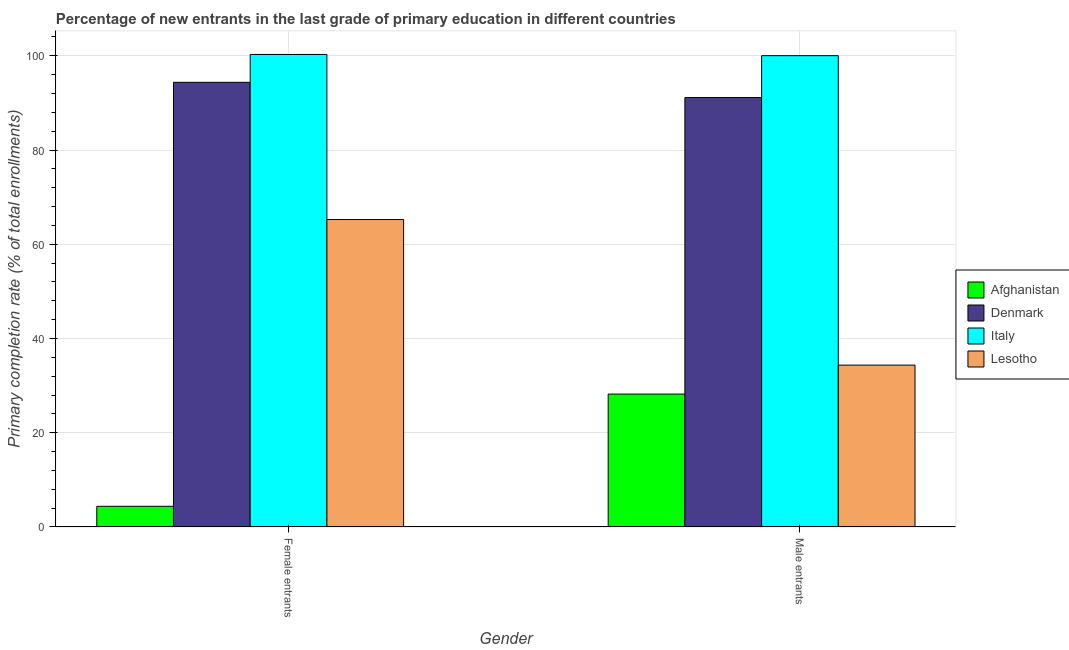How many different coloured bars are there?
Provide a short and direct response. 4. Are the number of bars per tick equal to the number of legend labels?
Provide a succinct answer. Yes. How many bars are there on the 2nd tick from the right?
Offer a very short reply. 4. What is the label of the 1st group of bars from the left?
Make the answer very short. Female entrants. What is the primary completion rate of male entrants in Afghanistan?
Provide a succinct answer. 28.21. Across all countries, what is the maximum primary completion rate of male entrants?
Your response must be concise. 100.02. Across all countries, what is the minimum primary completion rate of male entrants?
Provide a short and direct response. 28.21. In which country was the primary completion rate of female entrants maximum?
Your answer should be compact. Italy. In which country was the primary completion rate of male entrants minimum?
Offer a very short reply. Afghanistan. What is the total primary completion rate of female entrants in the graph?
Provide a short and direct response. 264.29. What is the difference between the primary completion rate of female entrants in Denmark and that in Italy?
Ensure brevity in your answer.  -5.91. What is the difference between the primary completion rate of female entrants in Denmark and the primary completion rate of male entrants in Afghanistan?
Your answer should be very brief. 66.16. What is the average primary completion rate of male entrants per country?
Provide a short and direct response. 63.43. What is the difference between the primary completion rate of female entrants and primary completion rate of male entrants in Denmark?
Keep it short and to the point. 3.23. In how many countries, is the primary completion rate of male entrants greater than 32 %?
Your response must be concise. 3. What is the ratio of the primary completion rate of male entrants in Italy to that in Lesotho?
Keep it short and to the point. 2.91. Is the primary completion rate of male entrants in Denmark less than that in Lesotho?
Give a very brief answer. No. In how many countries, is the primary completion rate of female entrants greater than the average primary completion rate of female entrants taken over all countries?
Give a very brief answer. 2. Are all the bars in the graph horizontal?
Keep it short and to the point. No. How many countries are there in the graph?
Ensure brevity in your answer.  4. What is the difference between two consecutive major ticks on the Y-axis?
Your response must be concise. 20. Does the graph contain any zero values?
Provide a succinct answer. No. How many legend labels are there?
Provide a short and direct response. 4. What is the title of the graph?
Your response must be concise. Percentage of new entrants in the last grade of primary education in different countries. What is the label or title of the X-axis?
Provide a succinct answer. Gender. What is the label or title of the Y-axis?
Give a very brief answer. Primary completion rate (% of total enrollments). What is the Primary completion rate (% of total enrollments) in Afghanistan in Female entrants?
Keep it short and to the point. 4.39. What is the Primary completion rate (% of total enrollments) of Denmark in Female entrants?
Your answer should be compact. 94.37. What is the Primary completion rate (% of total enrollments) of Italy in Female entrants?
Provide a short and direct response. 100.28. What is the Primary completion rate (% of total enrollments) of Lesotho in Female entrants?
Make the answer very short. 65.25. What is the Primary completion rate (% of total enrollments) of Afghanistan in Male entrants?
Keep it short and to the point. 28.21. What is the Primary completion rate (% of total enrollments) in Denmark in Male entrants?
Provide a short and direct response. 91.14. What is the Primary completion rate (% of total enrollments) in Italy in Male entrants?
Give a very brief answer. 100.02. What is the Primary completion rate (% of total enrollments) of Lesotho in Male entrants?
Provide a short and direct response. 34.35. Across all Gender, what is the maximum Primary completion rate (% of total enrollments) of Afghanistan?
Offer a very short reply. 28.21. Across all Gender, what is the maximum Primary completion rate (% of total enrollments) in Denmark?
Ensure brevity in your answer.  94.37. Across all Gender, what is the maximum Primary completion rate (% of total enrollments) of Italy?
Keep it short and to the point. 100.28. Across all Gender, what is the maximum Primary completion rate (% of total enrollments) of Lesotho?
Your answer should be very brief. 65.25. Across all Gender, what is the minimum Primary completion rate (% of total enrollments) in Afghanistan?
Keep it short and to the point. 4.39. Across all Gender, what is the minimum Primary completion rate (% of total enrollments) in Denmark?
Provide a short and direct response. 91.14. Across all Gender, what is the minimum Primary completion rate (% of total enrollments) in Italy?
Offer a terse response. 100.02. Across all Gender, what is the minimum Primary completion rate (% of total enrollments) in Lesotho?
Offer a very short reply. 34.35. What is the total Primary completion rate (% of total enrollments) in Afghanistan in the graph?
Offer a very short reply. 32.6. What is the total Primary completion rate (% of total enrollments) of Denmark in the graph?
Give a very brief answer. 185.51. What is the total Primary completion rate (% of total enrollments) of Italy in the graph?
Offer a very short reply. 200.3. What is the total Primary completion rate (% of total enrollments) in Lesotho in the graph?
Keep it short and to the point. 99.6. What is the difference between the Primary completion rate (% of total enrollments) of Afghanistan in Female entrants and that in Male entrants?
Your response must be concise. -23.82. What is the difference between the Primary completion rate (% of total enrollments) of Denmark in Female entrants and that in Male entrants?
Provide a succinct answer. 3.23. What is the difference between the Primary completion rate (% of total enrollments) of Italy in Female entrants and that in Male entrants?
Your answer should be very brief. 0.26. What is the difference between the Primary completion rate (% of total enrollments) of Lesotho in Female entrants and that in Male entrants?
Your answer should be very brief. 30.9. What is the difference between the Primary completion rate (% of total enrollments) in Afghanistan in Female entrants and the Primary completion rate (% of total enrollments) in Denmark in Male entrants?
Your answer should be very brief. -86.75. What is the difference between the Primary completion rate (% of total enrollments) of Afghanistan in Female entrants and the Primary completion rate (% of total enrollments) of Italy in Male entrants?
Give a very brief answer. -95.63. What is the difference between the Primary completion rate (% of total enrollments) of Afghanistan in Female entrants and the Primary completion rate (% of total enrollments) of Lesotho in Male entrants?
Keep it short and to the point. -29.96. What is the difference between the Primary completion rate (% of total enrollments) of Denmark in Female entrants and the Primary completion rate (% of total enrollments) of Italy in Male entrants?
Offer a terse response. -5.65. What is the difference between the Primary completion rate (% of total enrollments) of Denmark in Female entrants and the Primary completion rate (% of total enrollments) of Lesotho in Male entrants?
Provide a succinct answer. 60.02. What is the difference between the Primary completion rate (% of total enrollments) in Italy in Female entrants and the Primary completion rate (% of total enrollments) in Lesotho in Male entrants?
Your response must be concise. 65.93. What is the average Primary completion rate (% of total enrollments) of Afghanistan per Gender?
Provide a short and direct response. 16.3. What is the average Primary completion rate (% of total enrollments) of Denmark per Gender?
Keep it short and to the point. 92.75. What is the average Primary completion rate (% of total enrollments) in Italy per Gender?
Make the answer very short. 100.15. What is the average Primary completion rate (% of total enrollments) in Lesotho per Gender?
Make the answer very short. 49.8. What is the difference between the Primary completion rate (% of total enrollments) of Afghanistan and Primary completion rate (% of total enrollments) of Denmark in Female entrants?
Your answer should be compact. -89.98. What is the difference between the Primary completion rate (% of total enrollments) of Afghanistan and Primary completion rate (% of total enrollments) of Italy in Female entrants?
Provide a succinct answer. -95.89. What is the difference between the Primary completion rate (% of total enrollments) of Afghanistan and Primary completion rate (% of total enrollments) of Lesotho in Female entrants?
Provide a short and direct response. -60.86. What is the difference between the Primary completion rate (% of total enrollments) of Denmark and Primary completion rate (% of total enrollments) of Italy in Female entrants?
Provide a succinct answer. -5.91. What is the difference between the Primary completion rate (% of total enrollments) in Denmark and Primary completion rate (% of total enrollments) in Lesotho in Female entrants?
Provide a short and direct response. 29.12. What is the difference between the Primary completion rate (% of total enrollments) of Italy and Primary completion rate (% of total enrollments) of Lesotho in Female entrants?
Offer a very short reply. 35.03. What is the difference between the Primary completion rate (% of total enrollments) of Afghanistan and Primary completion rate (% of total enrollments) of Denmark in Male entrants?
Provide a short and direct response. -62.93. What is the difference between the Primary completion rate (% of total enrollments) of Afghanistan and Primary completion rate (% of total enrollments) of Italy in Male entrants?
Make the answer very short. -71.81. What is the difference between the Primary completion rate (% of total enrollments) of Afghanistan and Primary completion rate (% of total enrollments) of Lesotho in Male entrants?
Your answer should be very brief. -6.14. What is the difference between the Primary completion rate (% of total enrollments) of Denmark and Primary completion rate (% of total enrollments) of Italy in Male entrants?
Make the answer very short. -8.88. What is the difference between the Primary completion rate (% of total enrollments) in Denmark and Primary completion rate (% of total enrollments) in Lesotho in Male entrants?
Your answer should be very brief. 56.79. What is the difference between the Primary completion rate (% of total enrollments) of Italy and Primary completion rate (% of total enrollments) of Lesotho in Male entrants?
Ensure brevity in your answer.  65.67. What is the ratio of the Primary completion rate (% of total enrollments) of Afghanistan in Female entrants to that in Male entrants?
Offer a terse response. 0.16. What is the ratio of the Primary completion rate (% of total enrollments) in Denmark in Female entrants to that in Male entrants?
Give a very brief answer. 1.04. What is the ratio of the Primary completion rate (% of total enrollments) of Italy in Female entrants to that in Male entrants?
Offer a terse response. 1. What is the ratio of the Primary completion rate (% of total enrollments) of Lesotho in Female entrants to that in Male entrants?
Your answer should be compact. 1.9. What is the difference between the highest and the second highest Primary completion rate (% of total enrollments) in Afghanistan?
Provide a short and direct response. 23.82. What is the difference between the highest and the second highest Primary completion rate (% of total enrollments) of Denmark?
Ensure brevity in your answer.  3.23. What is the difference between the highest and the second highest Primary completion rate (% of total enrollments) of Italy?
Your answer should be compact. 0.26. What is the difference between the highest and the second highest Primary completion rate (% of total enrollments) of Lesotho?
Your response must be concise. 30.9. What is the difference between the highest and the lowest Primary completion rate (% of total enrollments) of Afghanistan?
Ensure brevity in your answer.  23.82. What is the difference between the highest and the lowest Primary completion rate (% of total enrollments) in Denmark?
Give a very brief answer. 3.23. What is the difference between the highest and the lowest Primary completion rate (% of total enrollments) in Italy?
Keep it short and to the point. 0.26. What is the difference between the highest and the lowest Primary completion rate (% of total enrollments) of Lesotho?
Offer a terse response. 30.9. 